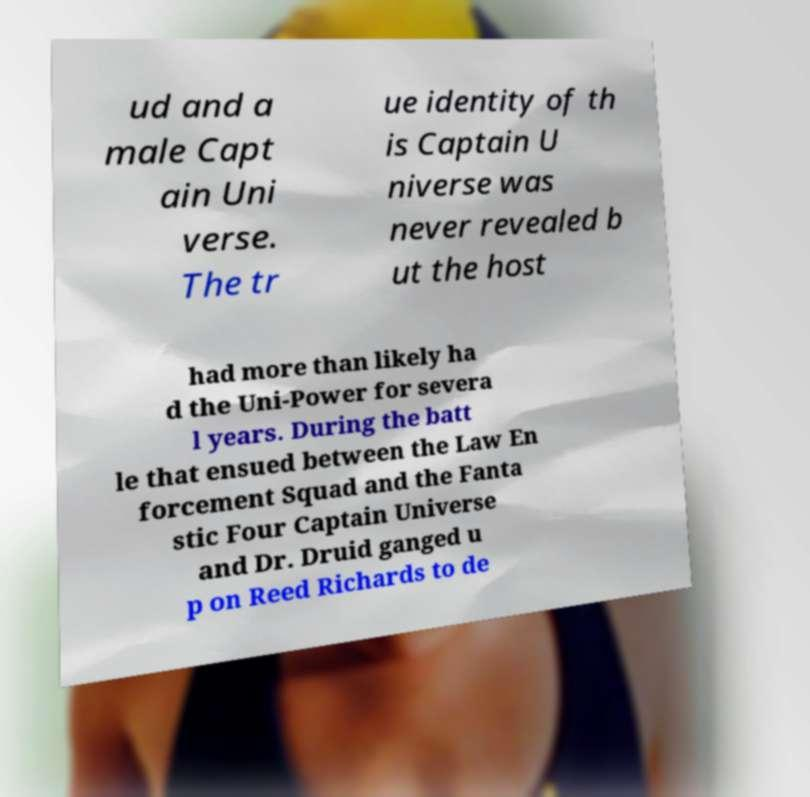I need the written content from this picture converted into text. Can you do that? ud and a male Capt ain Uni verse. The tr ue identity of th is Captain U niverse was never revealed b ut the host had more than likely ha d the Uni-Power for severa l years. During the batt le that ensued between the Law En forcement Squad and the Fanta stic Four Captain Universe and Dr. Druid ganged u p on Reed Richards to de 